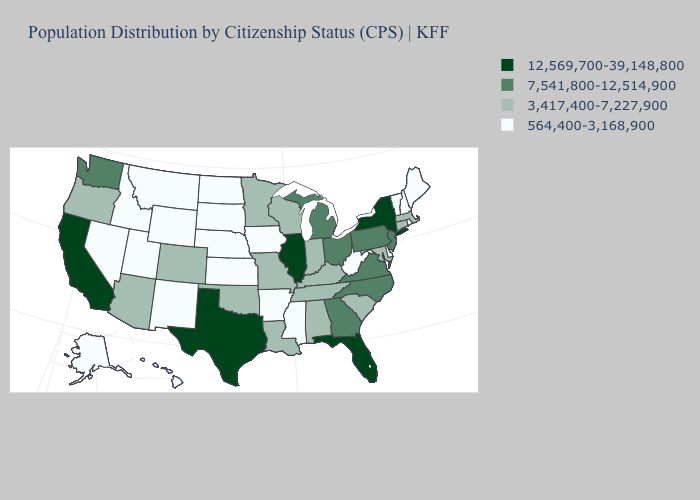Which states have the lowest value in the USA?
Keep it brief. Alaska, Arkansas, Delaware, Hawaii, Idaho, Iowa, Kansas, Maine, Mississippi, Montana, Nebraska, Nevada, New Hampshire, New Mexico, North Dakota, Rhode Island, South Dakota, Utah, Vermont, West Virginia, Wyoming. What is the value of Louisiana?
Be succinct. 3,417,400-7,227,900. Among the states that border New York , which have the highest value?
Give a very brief answer. New Jersey, Pennsylvania. Does Rhode Island have the lowest value in the Northeast?
Quick response, please. Yes. What is the value of Missouri?
Concise answer only. 3,417,400-7,227,900. Which states hav the highest value in the West?
Concise answer only. California. Name the states that have a value in the range 564,400-3,168,900?
Be succinct. Alaska, Arkansas, Delaware, Hawaii, Idaho, Iowa, Kansas, Maine, Mississippi, Montana, Nebraska, Nevada, New Hampshire, New Mexico, North Dakota, Rhode Island, South Dakota, Utah, Vermont, West Virginia, Wyoming. Does Kentucky have a higher value than Iowa?
Give a very brief answer. Yes. Name the states that have a value in the range 7,541,800-12,514,900?
Answer briefly. Georgia, Michigan, New Jersey, North Carolina, Ohio, Pennsylvania, Virginia, Washington. Which states have the highest value in the USA?
Short answer required. California, Florida, Illinois, New York, Texas. What is the value of Colorado?
Short answer required. 3,417,400-7,227,900. Does Massachusetts have the lowest value in the USA?
Answer briefly. No. What is the lowest value in states that border Missouri?
Concise answer only. 564,400-3,168,900. What is the value of Vermont?
Be succinct. 564,400-3,168,900. Is the legend a continuous bar?
Keep it brief. No. 